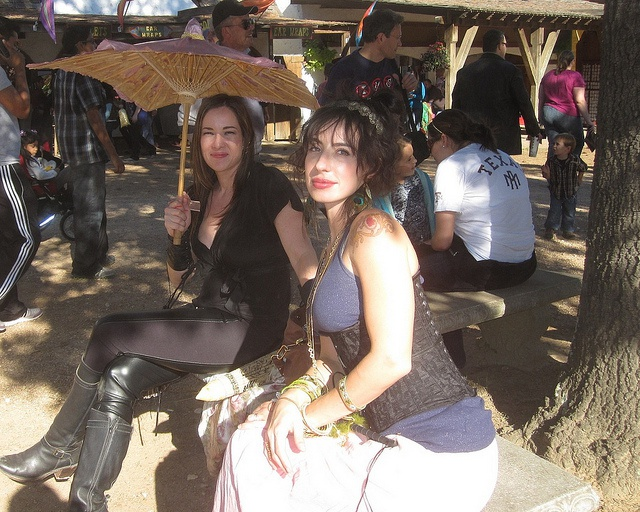Describe the objects in this image and their specific colors. I can see people in gray and white tones, people in gray and black tones, people in gray, black, white, and darkgray tones, umbrella in gray and brown tones, and people in gray and black tones in this image. 